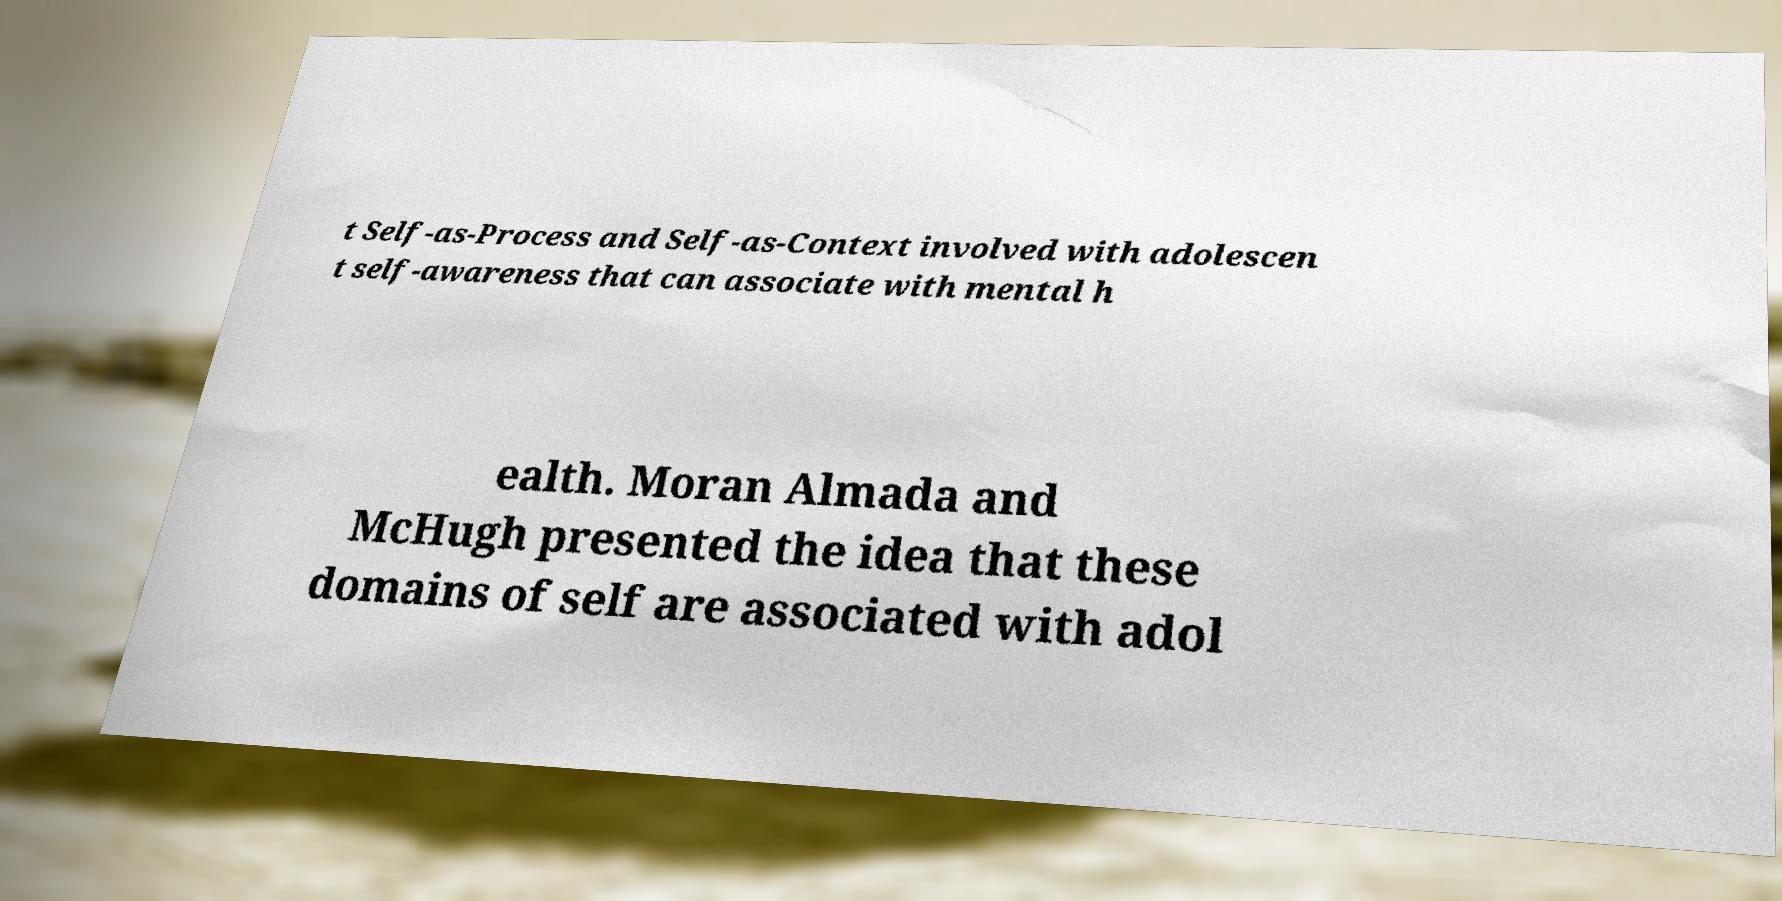Can you accurately transcribe the text from the provided image for me? t Self-as-Process and Self-as-Context involved with adolescen t self-awareness that can associate with mental h ealth. Moran Almada and McHugh presented the idea that these domains of self are associated with adol 